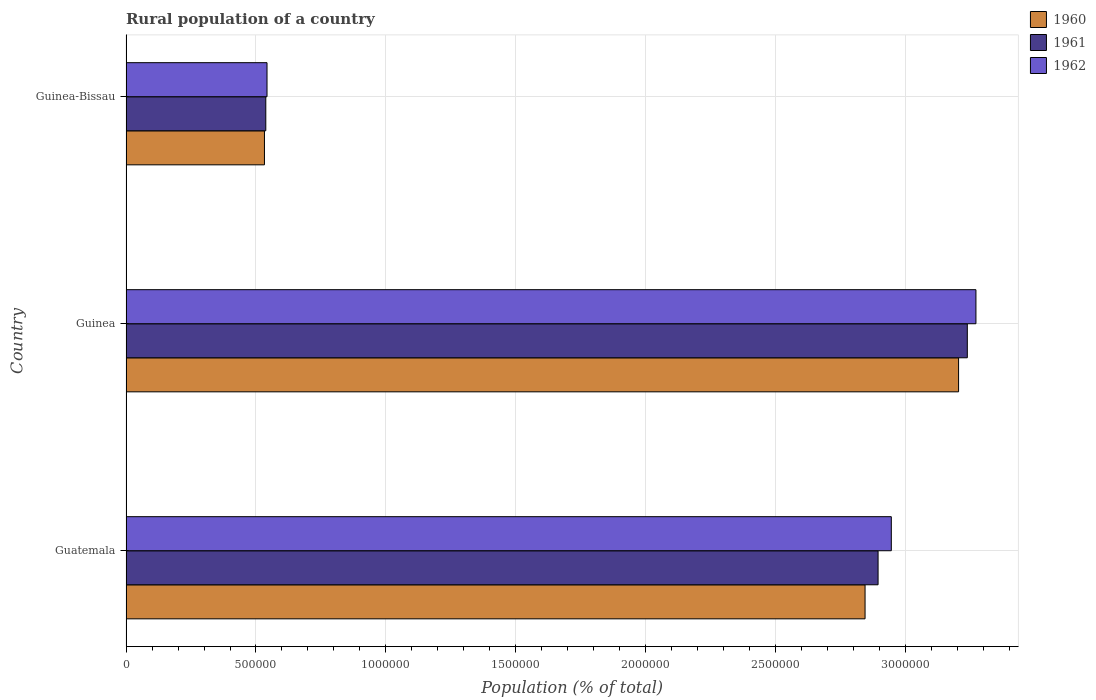Are the number of bars per tick equal to the number of legend labels?
Give a very brief answer. Yes. Are the number of bars on each tick of the Y-axis equal?
Keep it short and to the point. Yes. How many bars are there on the 3rd tick from the bottom?
Offer a very short reply. 3. What is the label of the 2nd group of bars from the top?
Make the answer very short. Guinea. In how many cases, is the number of bars for a given country not equal to the number of legend labels?
Provide a short and direct response. 0. What is the rural population in 1960 in Guinea?
Give a very brief answer. 3.20e+06. Across all countries, what is the maximum rural population in 1960?
Provide a succinct answer. 3.20e+06. Across all countries, what is the minimum rural population in 1962?
Your answer should be compact. 5.42e+05. In which country was the rural population in 1961 maximum?
Make the answer very short. Guinea. In which country was the rural population in 1961 minimum?
Give a very brief answer. Guinea-Bissau. What is the total rural population in 1961 in the graph?
Provide a succinct answer. 6.67e+06. What is the difference between the rural population in 1962 in Guatemala and that in Guinea?
Offer a terse response. -3.26e+05. What is the difference between the rural population in 1962 in Guatemala and the rural population in 1960 in Guinea-Bissau?
Provide a short and direct response. 2.41e+06. What is the average rural population in 1961 per country?
Give a very brief answer. 2.22e+06. What is the difference between the rural population in 1962 and rural population in 1960 in Guinea?
Provide a succinct answer. 6.67e+04. What is the ratio of the rural population in 1962 in Guatemala to that in Guinea-Bissau?
Your answer should be very brief. 5.43. What is the difference between the highest and the second highest rural population in 1961?
Your answer should be very brief. 3.43e+05. What is the difference between the highest and the lowest rural population in 1960?
Keep it short and to the point. 2.67e+06. Is the sum of the rural population in 1961 in Guatemala and Guinea-Bissau greater than the maximum rural population in 1960 across all countries?
Make the answer very short. Yes. What does the 1st bar from the bottom in Guinea represents?
Your response must be concise. 1960. How many countries are there in the graph?
Offer a terse response. 3. Does the graph contain grids?
Keep it short and to the point. Yes. Where does the legend appear in the graph?
Give a very brief answer. Top right. How are the legend labels stacked?
Your response must be concise. Vertical. What is the title of the graph?
Ensure brevity in your answer.  Rural population of a country. Does "2004" appear as one of the legend labels in the graph?
Provide a succinct answer. No. What is the label or title of the X-axis?
Keep it short and to the point. Population (% of total). What is the label or title of the Y-axis?
Ensure brevity in your answer.  Country. What is the Population (% of total) of 1960 in Guatemala?
Ensure brevity in your answer.  2.84e+06. What is the Population (% of total) in 1961 in Guatemala?
Your response must be concise. 2.89e+06. What is the Population (% of total) of 1962 in Guatemala?
Keep it short and to the point. 2.94e+06. What is the Population (% of total) of 1960 in Guinea?
Offer a very short reply. 3.20e+06. What is the Population (% of total) of 1961 in Guinea?
Your answer should be very brief. 3.24e+06. What is the Population (% of total) in 1962 in Guinea?
Your answer should be very brief. 3.27e+06. What is the Population (% of total) of 1960 in Guinea-Bissau?
Offer a terse response. 5.33e+05. What is the Population (% of total) of 1961 in Guinea-Bissau?
Ensure brevity in your answer.  5.38e+05. What is the Population (% of total) in 1962 in Guinea-Bissau?
Offer a terse response. 5.42e+05. Across all countries, what is the maximum Population (% of total) of 1960?
Ensure brevity in your answer.  3.20e+06. Across all countries, what is the maximum Population (% of total) of 1961?
Keep it short and to the point. 3.24e+06. Across all countries, what is the maximum Population (% of total) in 1962?
Make the answer very short. 3.27e+06. Across all countries, what is the minimum Population (% of total) in 1960?
Your answer should be compact. 5.33e+05. Across all countries, what is the minimum Population (% of total) of 1961?
Your answer should be very brief. 5.38e+05. Across all countries, what is the minimum Population (% of total) of 1962?
Ensure brevity in your answer.  5.42e+05. What is the total Population (% of total) in 1960 in the graph?
Provide a succinct answer. 6.58e+06. What is the total Population (% of total) of 1961 in the graph?
Your answer should be compact. 6.67e+06. What is the total Population (% of total) of 1962 in the graph?
Ensure brevity in your answer.  6.76e+06. What is the difference between the Population (% of total) in 1960 in Guatemala and that in Guinea?
Your answer should be very brief. -3.60e+05. What is the difference between the Population (% of total) in 1961 in Guatemala and that in Guinea?
Ensure brevity in your answer.  -3.43e+05. What is the difference between the Population (% of total) of 1962 in Guatemala and that in Guinea?
Your answer should be very brief. -3.26e+05. What is the difference between the Population (% of total) in 1960 in Guatemala and that in Guinea-Bissau?
Make the answer very short. 2.31e+06. What is the difference between the Population (% of total) of 1961 in Guatemala and that in Guinea-Bissau?
Offer a terse response. 2.36e+06. What is the difference between the Population (% of total) of 1962 in Guatemala and that in Guinea-Bissau?
Your answer should be very brief. 2.40e+06. What is the difference between the Population (% of total) in 1960 in Guinea and that in Guinea-Bissau?
Give a very brief answer. 2.67e+06. What is the difference between the Population (% of total) in 1961 in Guinea and that in Guinea-Bissau?
Offer a very short reply. 2.70e+06. What is the difference between the Population (% of total) in 1962 in Guinea and that in Guinea-Bissau?
Ensure brevity in your answer.  2.73e+06. What is the difference between the Population (% of total) of 1960 in Guatemala and the Population (% of total) of 1961 in Guinea?
Your answer should be very brief. -3.93e+05. What is the difference between the Population (% of total) of 1960 in Guatemala and the Population (% of total) of 1962 in Guinea?
Make the answer very short. -4.27e+05. What is the difference between the Population (% of total) in 1961 in Guatemala and the Population (% of total) in 1962 in Guinea?
Give a very brief answer. -3.76e+05. What is the difference between the Population (% of total) in 1960 in Guatemala and the Population (% of total) in 1961 in Guinea-Bissau?
Your answer should be very brief. 2.31e+06. What is the difference between the Population (% of total) of 1960 in Guatemala and the Population (% of total) of 1962 in Guinea-Bissau?
Provide a short and direct response. 2.30e+06. What is the difference between the Population (% of total) of 1961 in Guatemala and the Population (% of total) of 1962 in Guinea-Bissau?
Your answer should be very brief. 2.35e+06. What is the difference between the Population (% of total) in 1960 in Guinea and the Population (% of total) in 1961 in Guinea-Bissau?
Offer a very short reply. 2.67e+06. What is the difference between the Population (% of total) in 1960 in Guinea and the Population (% of total) in 1962 in Guinea-Bissau?
Keep it short and to the point. 2.66e+06. What is the difference between the Population (% of total) in 1961 in Guinea and the Population (% of total) in 1962 in Guinea-Bissau?
Offer a very short reply. 2.69e+06. What is the average Population (% of total) of 1960 per country?
Offer a terse response. 2.19e+06. What is the average Population (% of total) in 1961 per country?
Make the answer very short. 2.22e+06. What is the average Population (% of total) of 1962 per country?
Your answer should be very brief. 2.25e+06. What is the difference between the Population (% of total) of 1960 and Population (% of total) of 1961 in Guatemala?
Give a very brief answer. -5.01e+04. What is the difference between the Population (% of total) in 1960 and Population (% of total) in 1962 in Guatemala?
Your answer should be compact. -1.01e+05. What is the difference between the Population (% of total) of 1961 and Population (% of total) of 1962 in Guatemala?
Keep it short and to the point. -5.09e+04. What is the difference between the Population (% of total) in 1960 and Population (% of total) in 1961 in Guinea?
Give a very brief answer. -3.36e+04. What is the difference between the Population (% of total) in 1960 and Population (% of total) in 1962 in Guinea?
Provide a short and direct response. -6.67e+04. What is the difference between the Population (% of total) of 1961 and Population (% of total) of 1962 in Guinea?
Give a very brief answer. -3.31e+04. What is the difference between the Population (% of total) of 1960 and Population (% of total) of 1961 in Guinea-Bissau?
Your response must be concise. -5136. What is the difference between the Population (% of total) in 1960 and Population (% of total) in 1962 in Guinea-Bissau?
Offer a terse response. -9862. What is the difference between the Population (% of total) in 1961 and Population (% of total) in 1962 in Guinea-Bissau?
Your answer should be compact. -4726. What is the ratio of the Population (% of total) in 1960 in Guatemala to that in Guinea?
Give a very brief answer. 0.89. What is the ratio of the Population (% of total) in 1961 in Guatemala to that in Guinea?
Provide a short and direct response. 0.89. What is the ratio of the Population (% of total) in 1962 in Guatemala to that in Guinea?
Your response must be concise. 0.9. What is the ratio of the Population (% of total) in 1960 in Guatemala to that in Guinea-Bissau?
Your answer should be very brief. 5.34. What is the ratio of the Population (% of total) of 1961 in Guatemala to that in Guinea-Bissau?
Keep it short and to the point. 5.38. What is the ratio of the Population (% of total) of 1962 in Guatemala to that in Guinea-Bissau?
Provide a succinct answer. 5.43. What is the ratio of the Population (% of total) in 1960 in Guinea to that in Guinea-Bissau?
Provide a short and direct response. 6.01. What is the ratio of the Population (% of total) in 1961 in Guinea to that in Guinea-Bissau?
Ensure brevity in your answer.  6.02. What is the ratio of the Population (% of total) in 1962 in Guinea to that in Guinea-Bissau?
Keep it short and to the point. 6.03. What is the difference between the highest and the second highest Population (% of total) of 1960?
Provide a succinct answer. 3.60e+05. What is the difference between the highest and the second highest Population (% of total) in 1961?
Ensure brevity in your answer.  3.43e+05. What is the difference between the highest and the second highest Population (% of total) in 1962?
Your answer should be compact. 3.26e+05. What is the difference between the highest and the lowest Population (% of total) of 1960?
Give a very brief answer. 2.67e+06. What is the difference between the highest and the lowest Population (% of total) of 1961?
Provide a short and direct response. 2.70e+06. What is the difference between the highest and the lowest Population (% of total) in 1962?
Your response must be concise. 2.73e+06. 